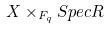<formula> <loc_0><loc_0><loc_500><loc_500>X \times _ { F _ { q } } S p e c R</formula> 